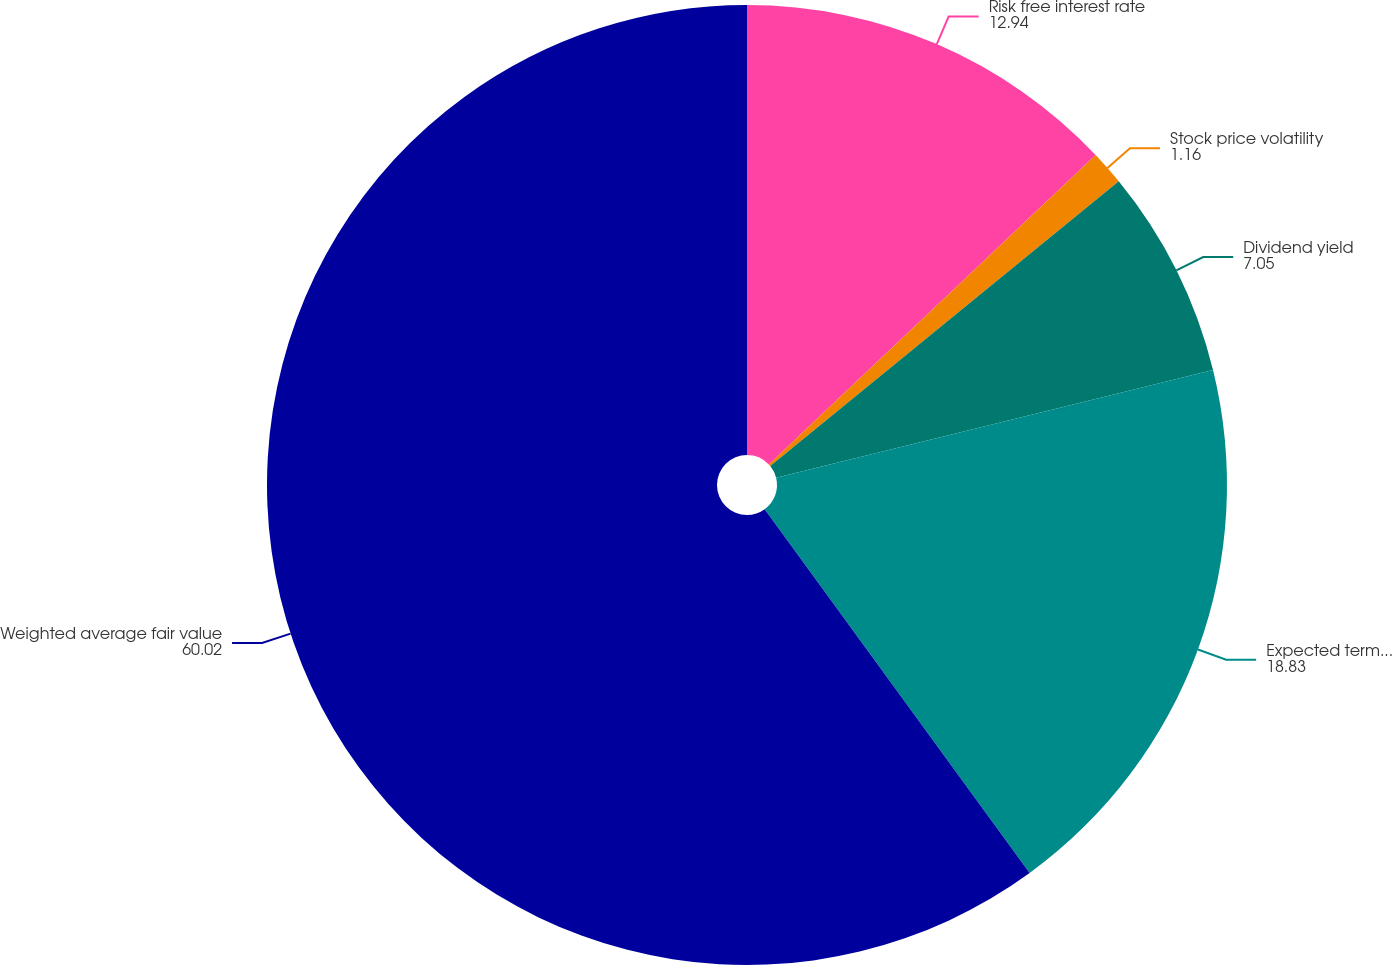Convert chart to OTSL. <chart><loc_0><loc_0><loc_500><loc_500><pie_chart><fcel>Risk free interest rate<fcel>Stock price volatility<fcel>Dividend yield<fcel>Expected term in years<fcel>Weighted average fair value<nl><fcel>12.94%<fcel>1.16%<fcel>7.05%<fcel>18.83%<fcel>60.02%<nl></chart> 